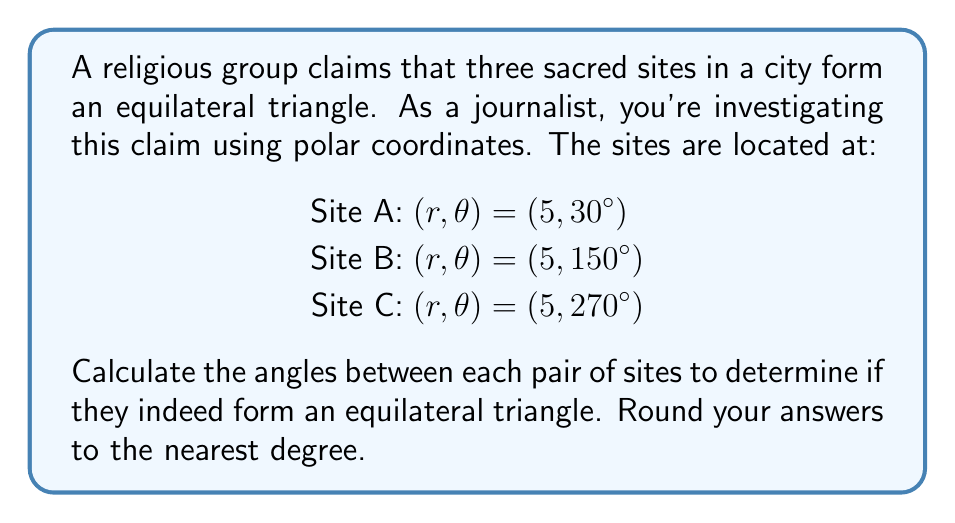Provide a solution to this math problem. To solve this problem, we need to follow these steps:

1) Convert polar coordinates to Cartesian coordinates:
   $x = r \cos(\theta)$, $y = r \sin(\theta)$

   Site A: $x_A = 5 \cos(30°)$, $y_A = 5 \sin(30°)$
   Site B: $x_B = 5 \cos(150°)$, $y_B = 5 \sin(150°)$
   Site C: $x_C = 5 \cos(270°)$, $y_C = 5 \sin(270°)$

2) Calculate vectors between sites:
   $\vec{AB} = (x_B - x_A, y_B - y_A)$
   $\vec{BC} = (x_C - x_B, y_C - y_B)$
   $\vec{CA} = (x_A - x_C, y_A - y_C)$

3) Use dot product formula to find angles:
   $\cos(\angle ABC) = \frac{\vec{AB} \cdot \vec{BC}}{|\vec{AB}||\vec{BC}|}$
   $\cos(\angle BCA) = \frac{\vec{BC} \cdot \vec{CA}}{|\vec{BC}||\vec{CA}|}$
   $\cos(\angle CAB) = \frac{\vec{CA} \cdot \vec{AB}}{|\vec{CA}||\vec{AB}|}$

4) Take inverse cosine (arccos) of each result and convert to degrees.

5) Round to nearest degree.

Calculating:
$\angle ABC = \arccos(-0.5) \approx 120°$
$\angle BCA = \arccos(-0.5) \approx 120°$
$\angle CAB = \arccos(-0.5) \approx 120°$

All angles are 120°, confirming an equilateral triangle.
Answer: 120°, 120°, 120° 